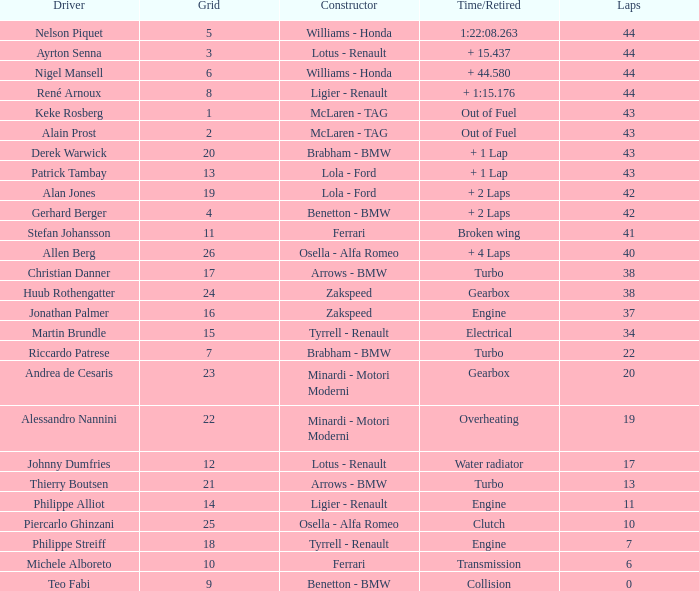Tell me the time/retired for Laps of 42 and Grids of 4 + 2 Laps. 